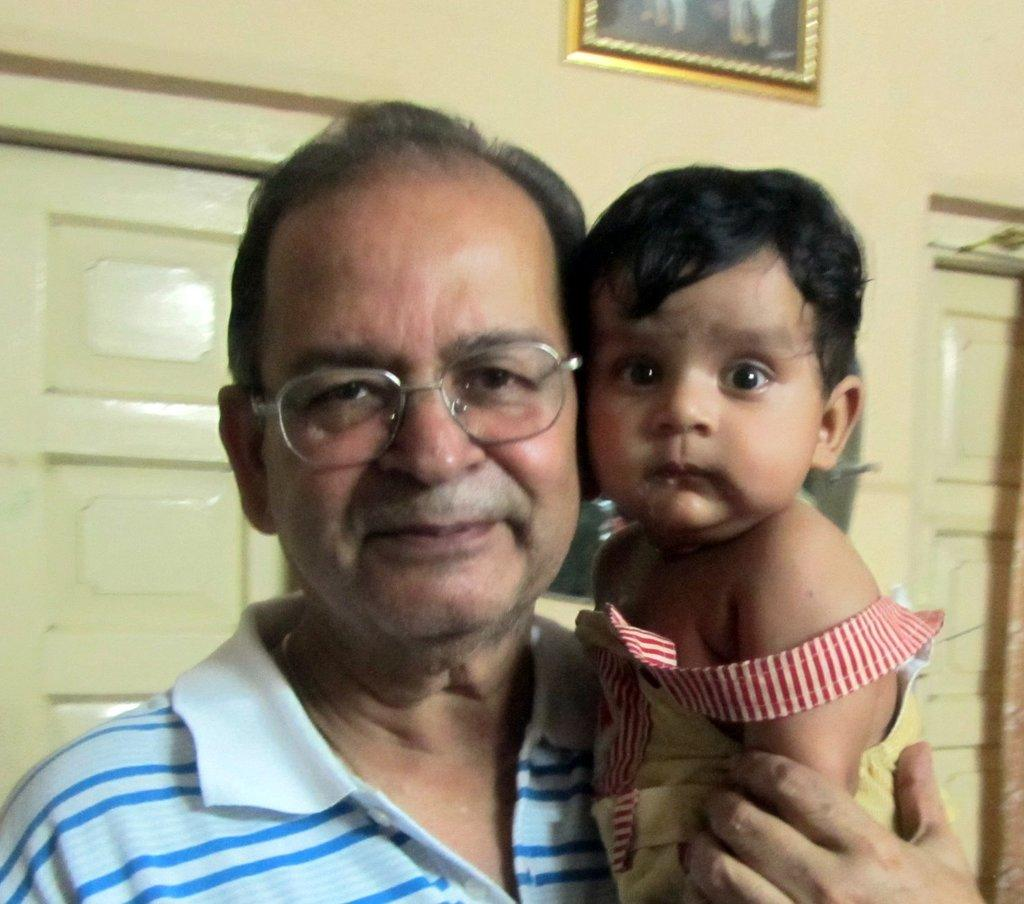Who is present in the image? There is a man and a baby in the image. What can be seen in the background of the image? There is a wall in the background of the image. What features are present on the wall? There are doors on the wall. Is there any additional decoration or object on the wall? There may be a frame present on the wall. What type of camp can be seen in the background of the image? There is no camp present in the image; it features a wall with doors and possibly a frame. 